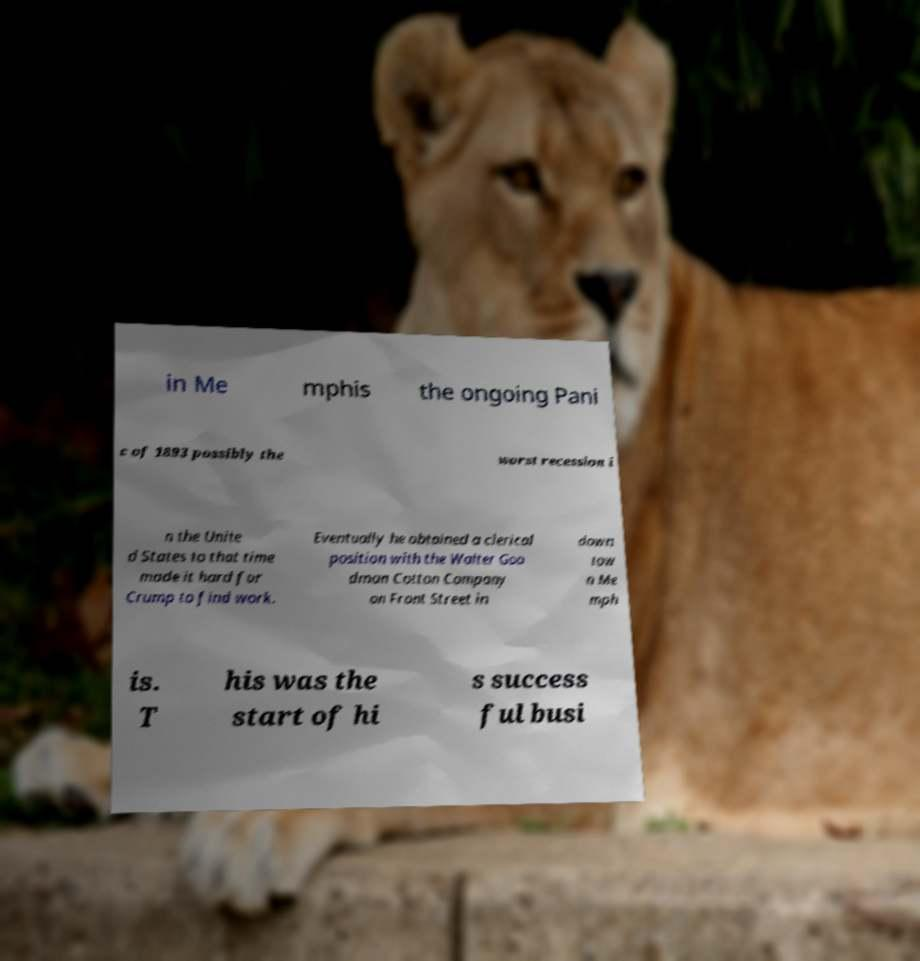What messages or text are displayed in this image? I need them in a readable, typed format. in Me mphis the ongoing Pani c of 1893 possibly the worst recession i n the Unite d States to that time made it hard for Crump to find work. Eventually he obtained a clerical position with the Walter Goo dman Cotton Company on Front Street in down tow n Me mph is. T his was the start of hi s success ful busi 